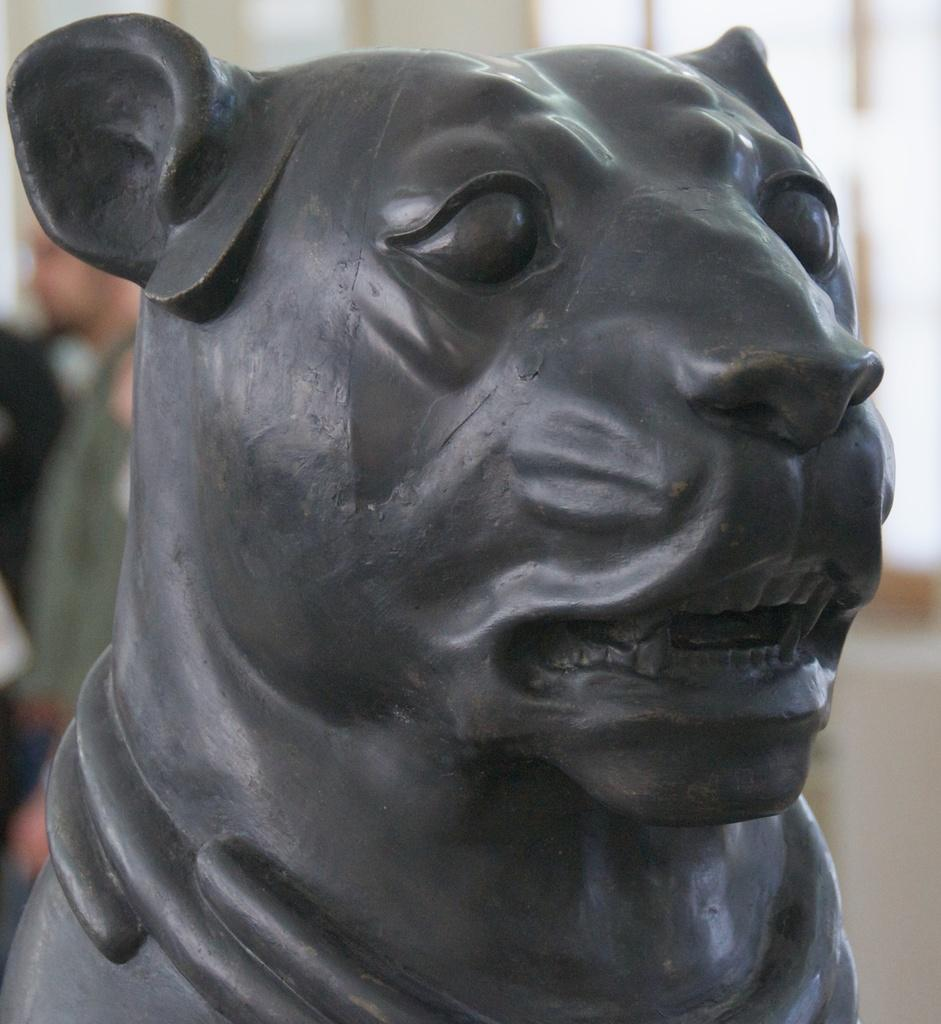What is the main subject in the center of the image? There is a sculpture in the center of the image. Can you describe the person on the left side of the image? There is a person on the left side of the image, but no specific details about their appearance or actions are provided. What type of box is being used by the owner of the sculpture in the image? There is no box or owner mentioned in the image, as it only features a sculpture and a person. 